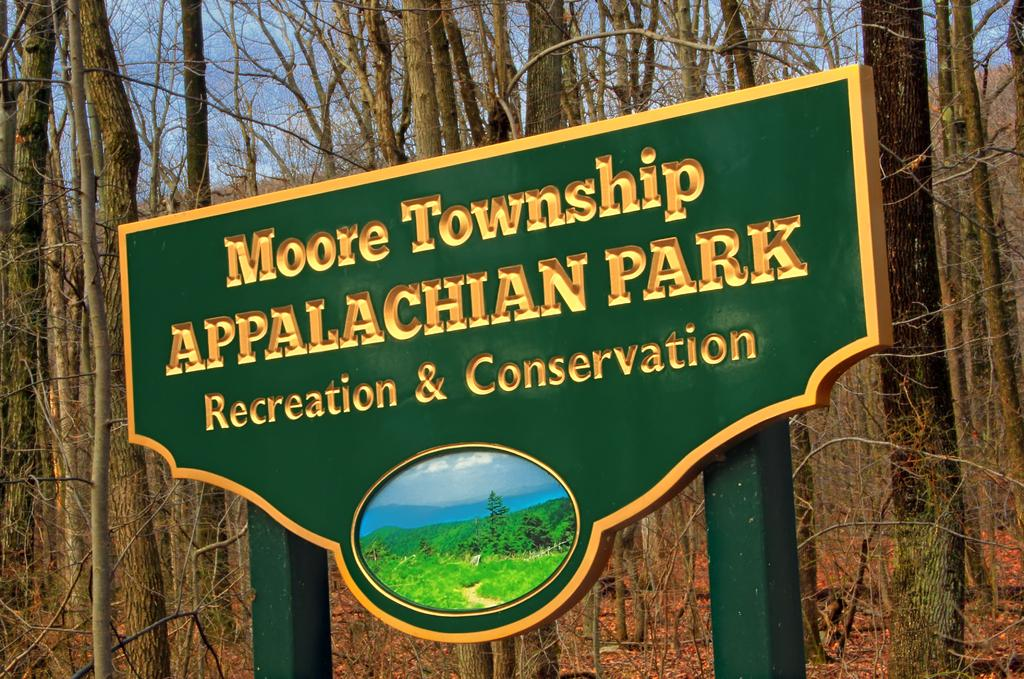What is the main object in the center of the image? There is a sign pole in the center of the image. What information is displayed on the sign? The sign on the pole reads "Appalachian Park." What can be seen in the background of the image? There are trees in the background of the image. What type of ornament is hanging from the sign pole in the image? There is no ornament hanging from the sign pole in the image. Can you tell me what pen the person used to write the sign? There is no person or pen mentioned in the image; the focus is on the sign pole and the text displayed on the sign. 